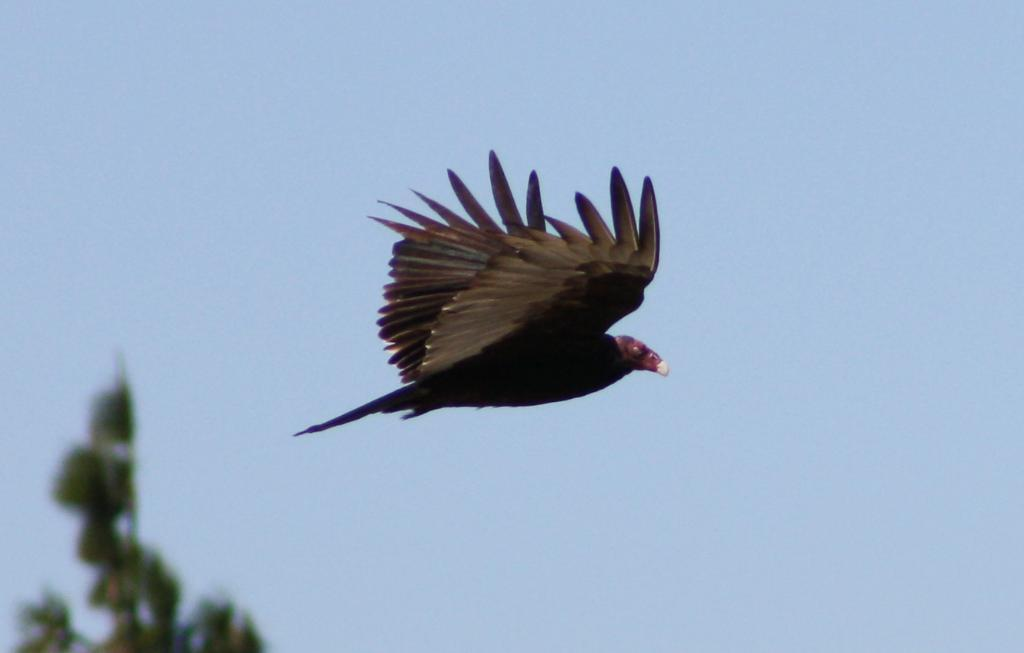What is the main subject in the center of the image? There is a bird flying in the center of the image. What can be seen towards the left side of the image? There is an object towards the left side of the image. Can you describe the background of the image? The background of the image is blurred. How many beds are visible in the image? There are no beds present in the image. What type of rail can be seen in the image? There is no rail present in the image. 